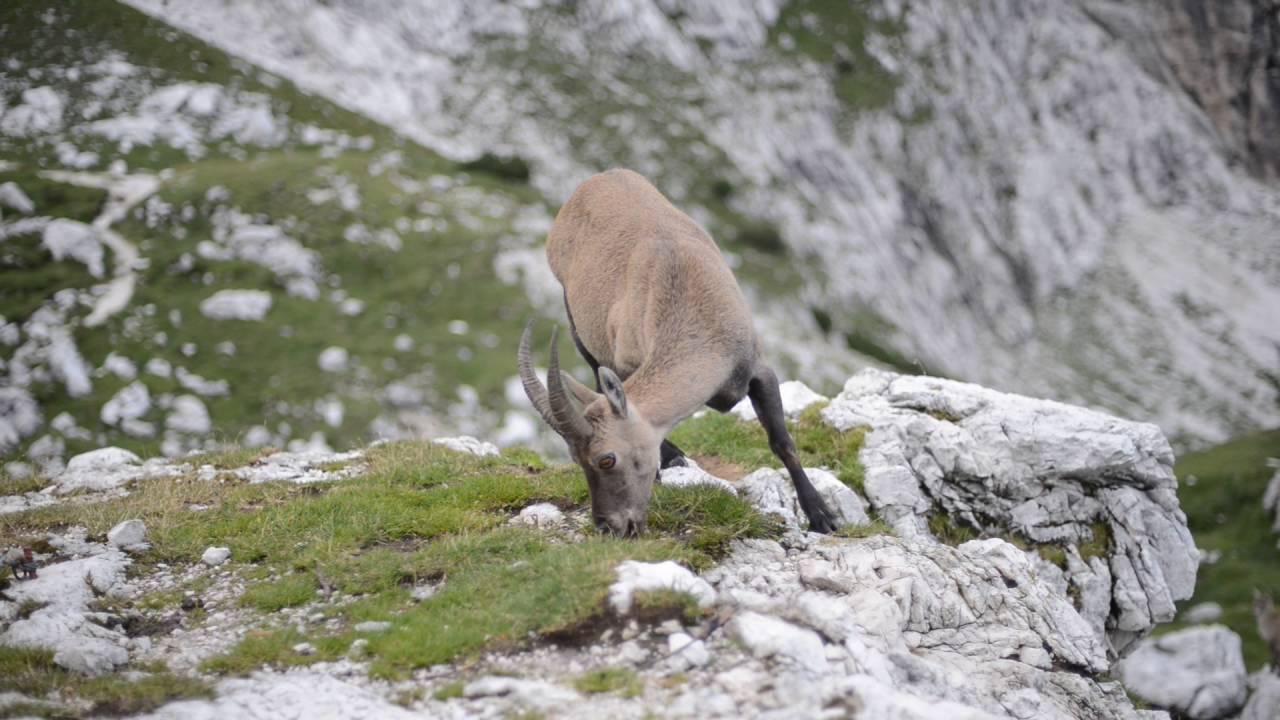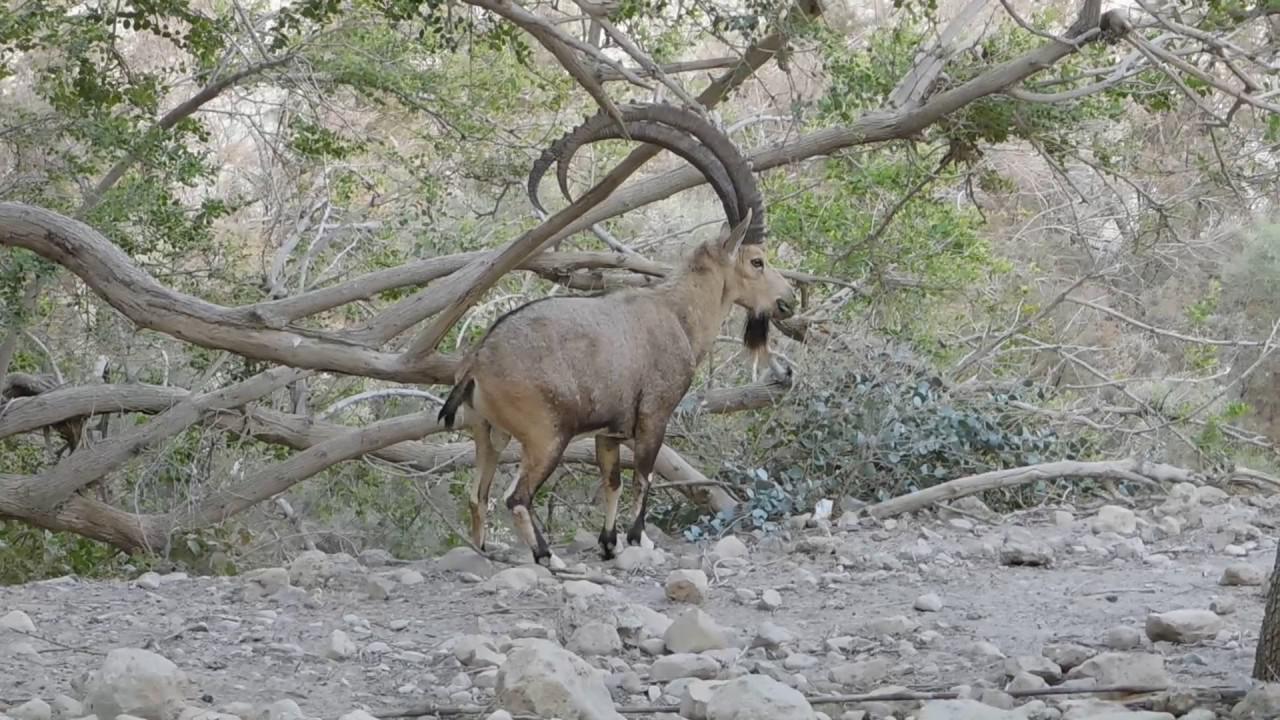The first image is the image on the left, the second image is the image on the right. For the images shown, is this caption "There is a single horned animal in each of the images." true? Answer yes or no. Yes. The first image is the image on the left, the second image is the image on the right. For the images shown, is this caption "An image shows one right-facing horned animal with moulting coat, standing in a green grassy area." true? Answer yes or no. No. 